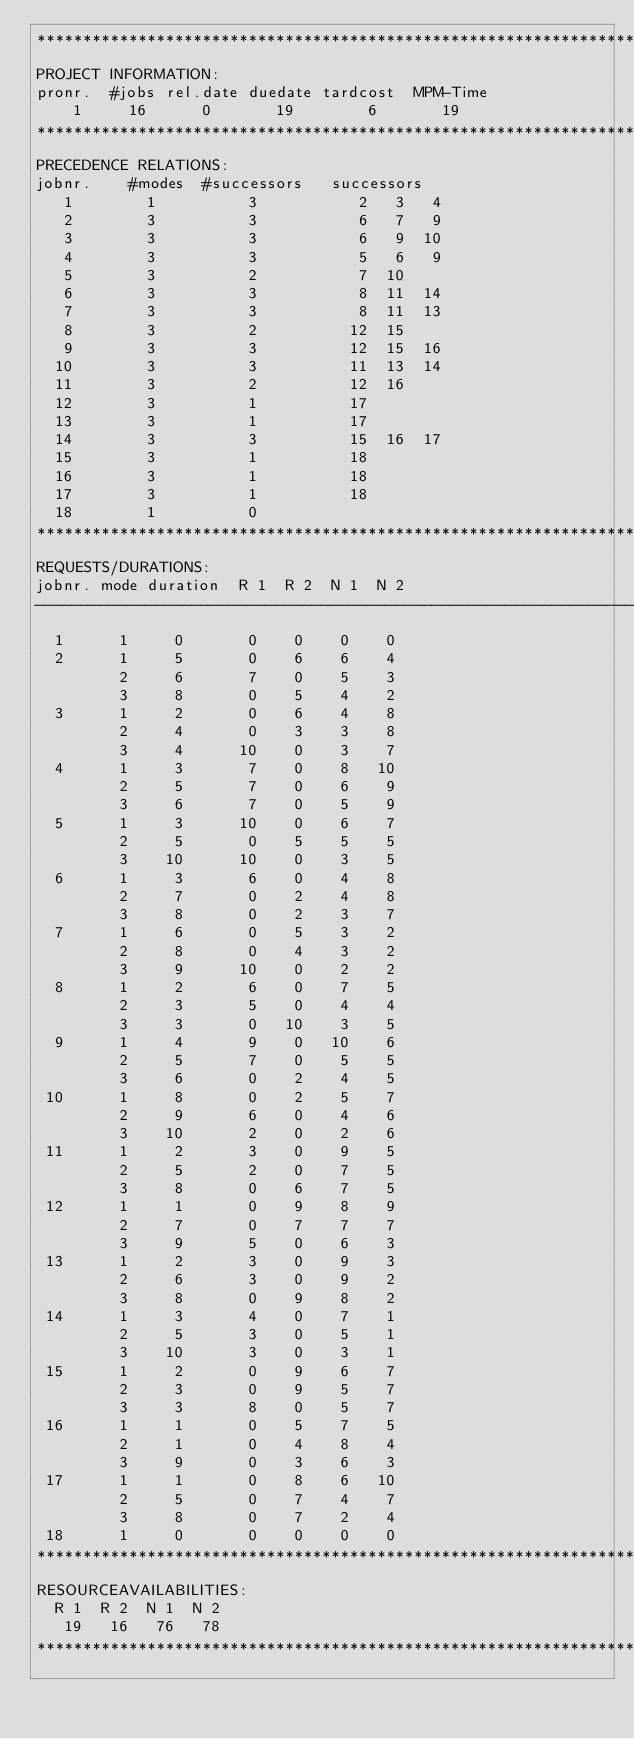<code> <loc_0><loc_0><loc_500><loc_500><_ObjectiveC_>************************************************************************
PROJECT INFORMATION:
pronr.  #jobs rel.date duedate tardcost  MPM-Time
    1     16      0       19        6       19
************************************************************************
PRECEDENCE RELATIONS:
jobnr.    #modes  #successors   successors
   1        1          3           2   3   4
   2        3          3           6   7   9
   3        3          3           6   9  10
   4        3          3           5   6   9
   5        3          2           7  10
   6        3          3           8  11  14
   7        3          3           8  11  13
   8        3          2          12  15
   9        3          3          12  15  16
  10        3          3          11  13  14
  11        3          2          12  16
  12        3          1          17
  13        3          1          17
  14        3          3          15  16  17
  15        3          1          18
  16        3          1          18
  17        3          1          18
  18        1          0        
************************************************************************
REQUESTS/DURATIONS:
jobnr. mode duration  R 1  R 2  N 1  N 2
------------------------------------------------------------------------
  1      1     0       0    0    0    0
  2      1     5       0    6    6    4
         2     6       7    0    5    3
         3     8       0    5    4    2
  3      1     2       0    6    4    8
         2     4       0    3    3    8
         3     4      10    0    3    7
  4      1     3       7    0    8   10
         2     5       7    0    6    9
         3     6       7    0    5    9
  5      1     3      10    0    6    7
         2     5       0    5    5    5
         3    10      10    0    3    5
  6      1     3       6    0    4    8
         2     7       0    2    4    8
         3     8       0    2    3    7
  7      1     6       0    5    3    2
         2     8       0    4    3    2
         3     9      10    0    2    2
  8      1     2       6    0    7    5
         2     3       5    0    4    4
         3     3       0   10    3    5
  9      1     4       9    0   10    6
         2     5       7    0    5    5
         3     6       0    2    4    5
 10      1     8       0    2    5    7
         2     9       6    0    4    6
         3    10       2    0    2    6
 11      1     2       3    0    9    5
         2     5       2    0    7    5
         3     8       0    6    7    5
 12      1     1       0    9    8    9
         2     7       0    7    7    7
         3     9       5    0    6    3
 13      1     2       3    0    9    3
         2     6       3    0    9    2
         3     8       0    9    8    2
 14      1     3       4    0    7    1
         2     5       3    0    5    1
         3    10       3    0    3    1
 15      1     2       0    9    6    7
         2     3       0    9    5    7
         3     3       8    0    5    7
 16      1     1       0    5    7    5
         2     1       0    4    8    4
         3     9       0    3    6    3
 17      1     1       0    8    6   10
         2     5       0    7    4    7
         3     8       0    7    2    4
 18      1     0       0    0    0    0
************************************************************************
RESOURCEAVAILABILITIES:
  R 1  R 2  N 1  N 2
   19   16   76   78
************************************************************************
</code> 